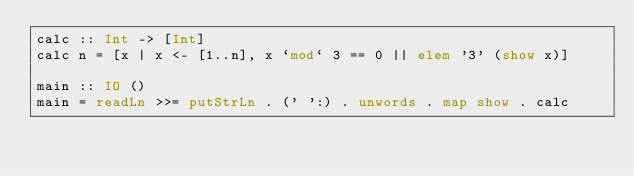Convert code to text. <code><loc_0><loc_0><loc_500><loc_500><_Haskell_>calc :: Int -> [Int]
calc n = [x | x <- [1..n], x `mod` 3 == 0 || elem '3' (show x)]

main :: IO ()
main = readLn >>= putStrLn . (' ':) . unwords . map show . calc</code> 